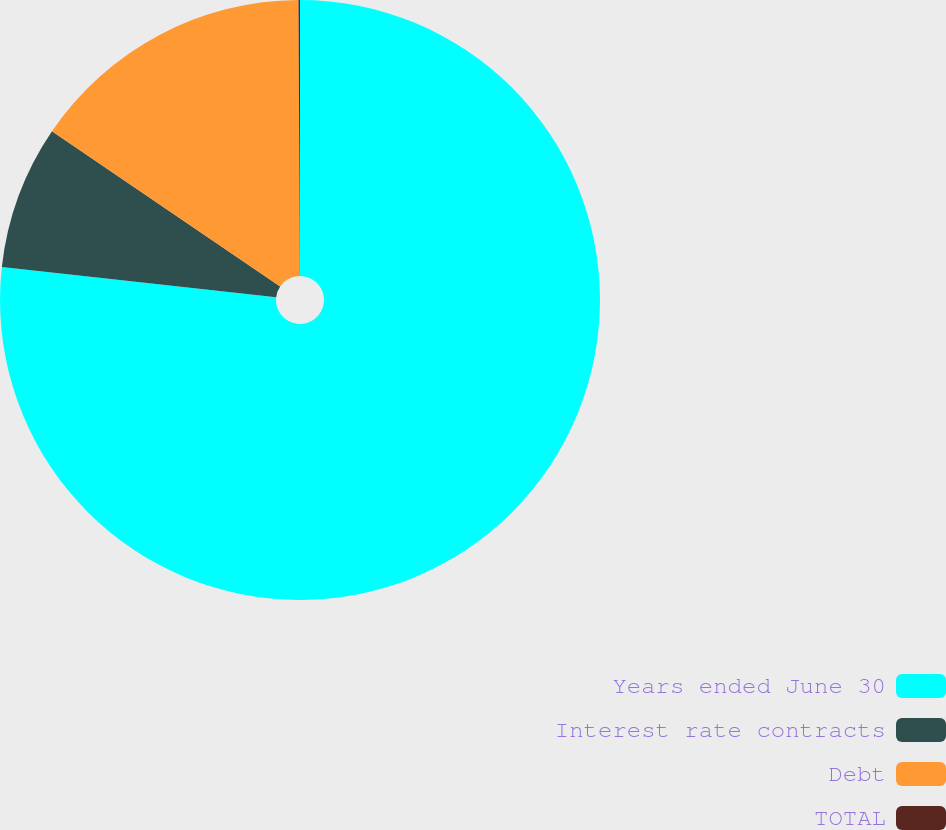<chart> <loc_0><loc_0><loc_500><loc_500><pie_chart><fcel>Years ended June 30<fcel>Interest rate contracts<fcel>Debt<fcel>TOTAL<nl><fcel>76.76%<fcel>7.75%<fcel>15.41%<fcel>0.08%<nl></chart> 